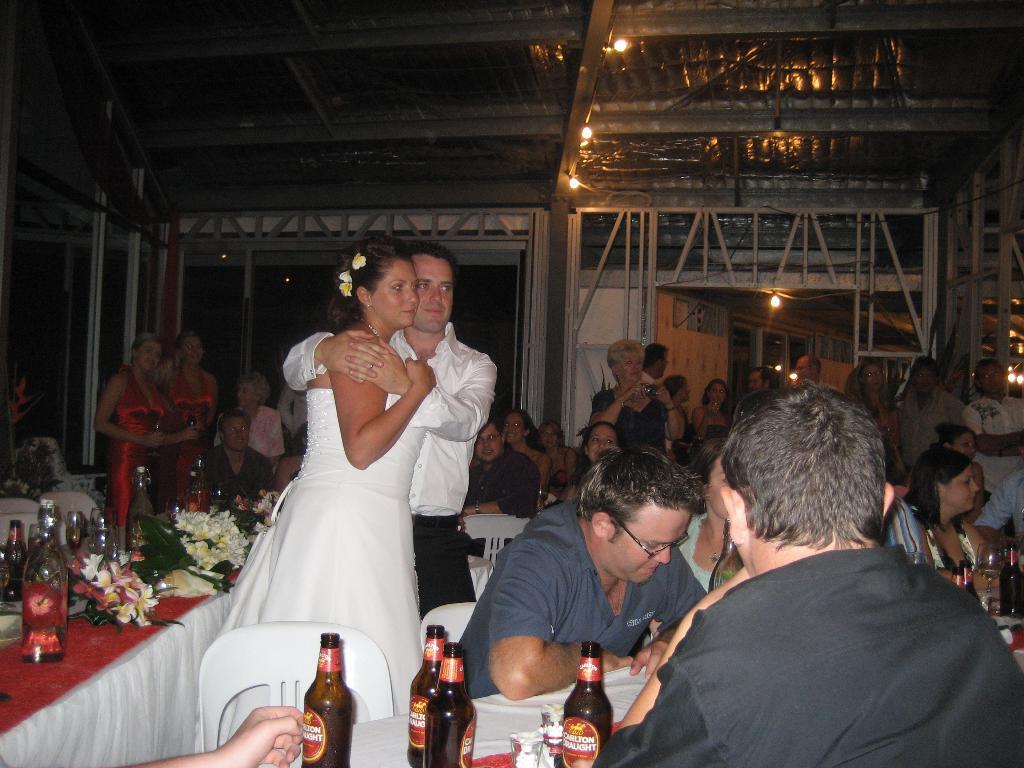Please provide a concise description of this image. In this image in the front there are persons sitting and there are bottles on the table. In the center there are persons standing and hugging each other and there is a table and on the table there are bottles, flowers. In the background there are persons standing and sitting, there are lights and there is glass on the doors. 